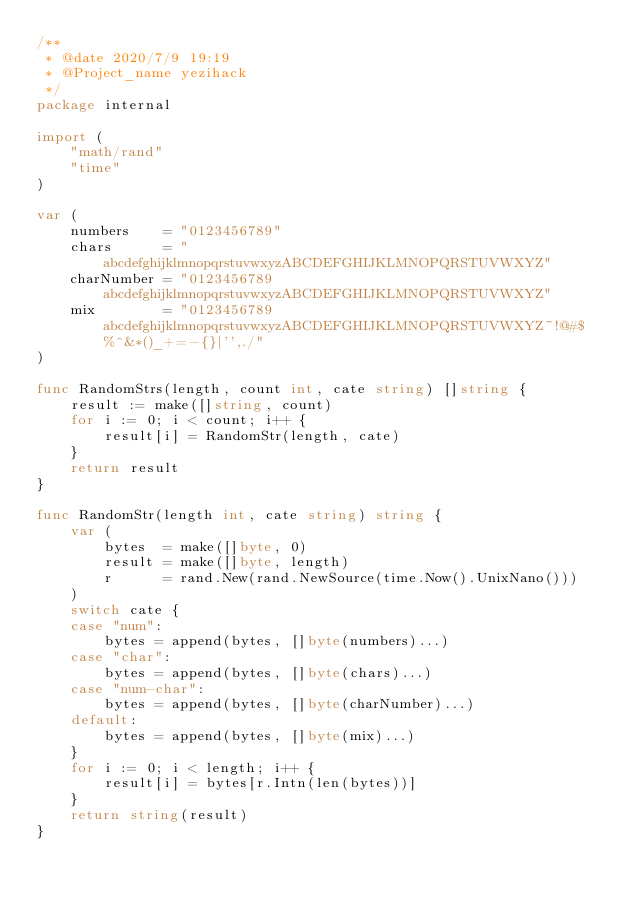<code> <loc_0><loc_0><loc_500><loc_500><_Go_>/**
 * @date 2020/7/9 19:19
 * @Project_name yezihack
 */
package internal

import (
	"math/rand"
	"time"
)

var (
	numbers    = "0123456789"
	chars      = "abcdefghijklmnopqrstuvwxyzABCDEFGHIJKLMNOPQRSTUVWXYZ"
	charNumber = "0123456789abcdefghijklmnopqrstuvwxyzABCDEFGHIJKLMNOPQRSTUVWXYZ"
	mix        = "0123456789abcdefghijklmnopqrstuvwxyzABCDEFGHIJKLMNOPQRSTUVWXYZ~!@#$%^&*()_+=-{}|'',./"
)

func RandomStrs(length, count int, cate string) []string {
	result := make([]string, count)
	for i := 0; i < count; i++ {
		result[i] = RandomStr(length, cate)
	}
	return result
}

func RandomStr(length int, cate string) string {
	var (
		bytes  = make([]byte, 0)
		result = make([]byte, length)
		r      = rand.New(rand.NewSource(time.Now().UnixNano()))
	)
	switch cate {
	case "num":
		bytes = append(bytes, []byte(numbers)...)
	case "char":
		bytes = append(bytes, []byte(chars)...)
	case "num-char":
		bytes = append(bytes, []byte(charNumber)...)
	default:
		bytes = append(bytes, []byte(mix)...)
	}
	for i := 0; i < length; i++ {
		result[i] = bytes[r.Intn(len(bytes))]
	}
	return string(result)
}
</code> 